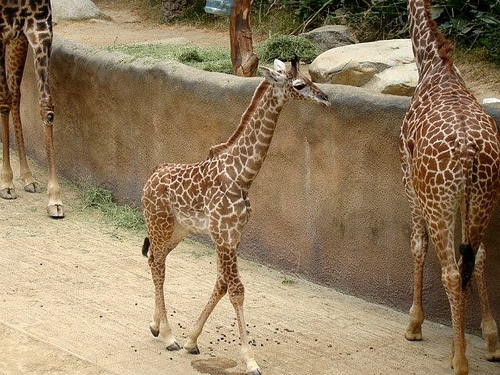Describe the objects in this image and their specific colors. I can see giraffe in maroon, gray, and black tones, giraffe in maroon, gray, and tan tones, and giraffe in darkgray, black, maroon, and gray tones in this image. 